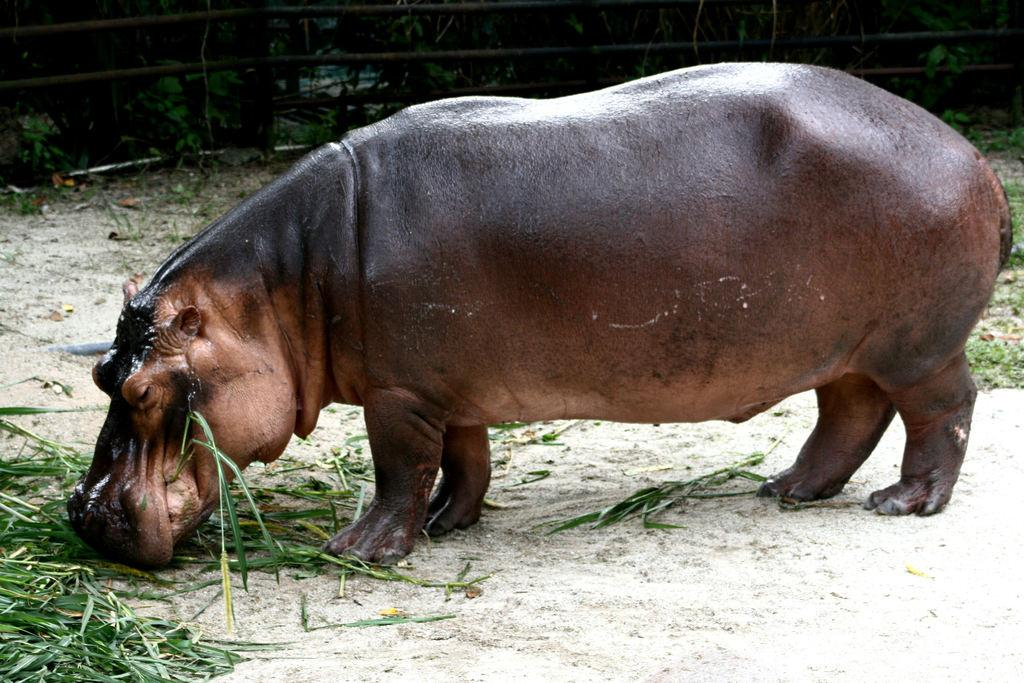What animal is the main subject of the image? There is a hippopotamus in the image. What is the hippopotamus doing in the image? The hippopotamus is eating grass. What can be seen in the background of the image? There is a fence and leaves in the background of the image. How many nails can be seen in the image? There are no nails present in the image. What type of answer is the hippopotamus providing in the image? The hippopotamus is not providing any answer in the image; it is eating grass. 